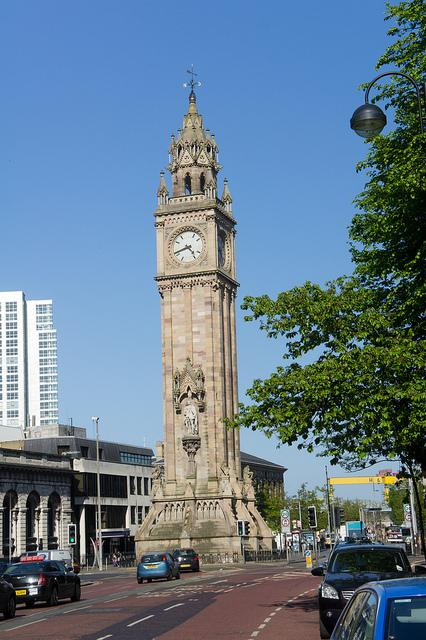What is near the tower? building 